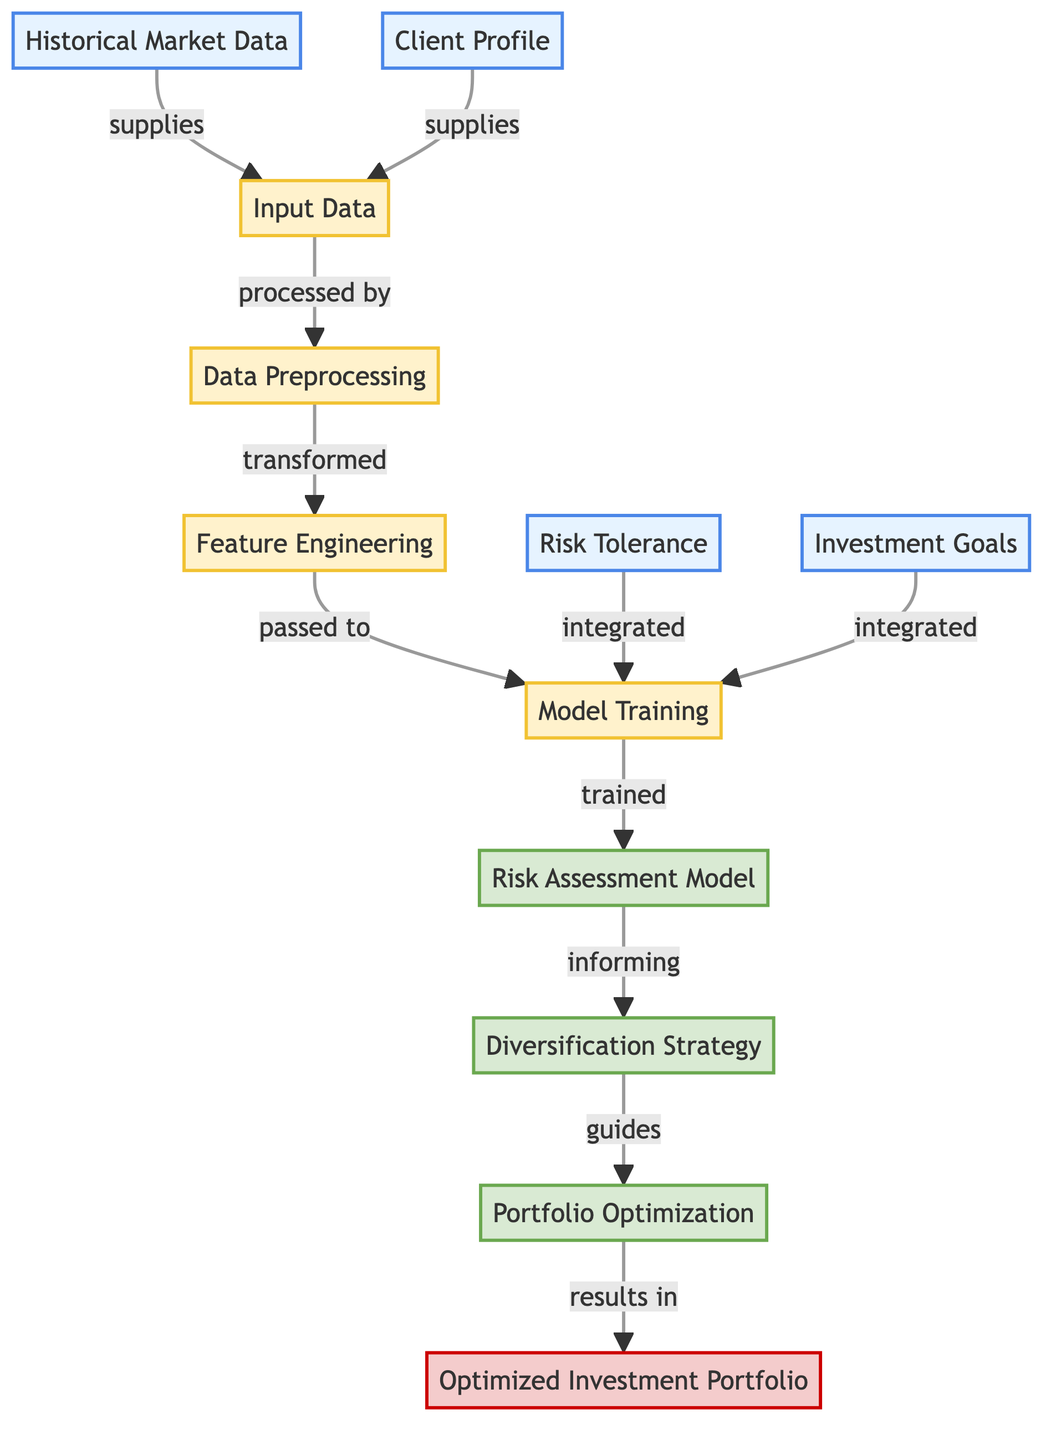What are the input data sources used in this diagram? The diagram shows four input data sources: Historical Market Data, Client Profile, Risk Tolerance, and Investment Goals. These sources feed into the Input Data node.
Answer: Historical Market Data, Client Profile, Risk Tolerance, Investment Goals How many processes are there in the diagram? The diagram has four processes: Input Data, Data Preprocessing, Feature Engineering, and Model Training. Each of these processes is connected to others in sequence.
Answer: Four Which model informs the diversification strategy? The diagram indicates that the Risk Assessment Model informs the Diversification Strategy, illustrating the workflow from model training to strategy development.
Answer: Risk Assessment Model Which component leads to the Optimized Investment Portfolio? The diagram shows that the Portfolio Optimization component results in the Optimized Investment Portfolio. This indicates the final step in the workflow leading to the output.
Answer: Portfolio Optimization What is the role of risk tolerance in the model? The Risk Tolerance is integrated during the Model Training, indicating that it plays a critical role in shaping the model's predictions and outputs.
Answer: Integrated How does the output relate to the input data? The input data is processed through a series of steps (Data Preprocessing, Feature Engineering, Model Training) before guiding the decision-making process for Portfolio Optimization, which then leads to the final output.
Answer: Processed through multiple steps What is the last stage of the risk assessment model process? The last stage mentioned in the diagram is the output, which is the Optimized Investment Portfolio, indicating that all previous steps culminate in this final result.
Answer: Optimized Investment Portfolio What is the relationship between Feature Engineering and Model Training? The Feature Engineering process is passed to Model Training, which indicates that the features extracted during engineering directly impact the training phase of the risk assessment model.
Answer: Passed to What is the initial step in the flowchart? The initial step involves the collection of input data from the various sources such as Historical Market Data and Client Profile, which serves as the starting point of the analysis.
Answer: Input Data 